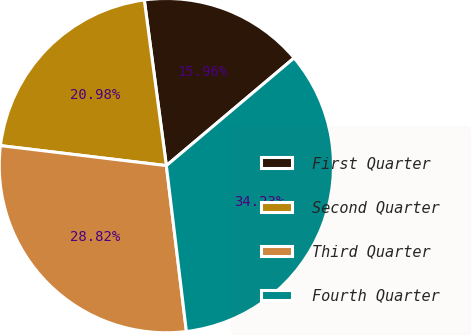<chart> <loc_0><loc_0><loc_500><loc_500><pie_chart><fcel>First Quarter<fcel>Second Quarter<fcel>Third Quarter<fcel>Fourth Quarter<nl><fcel>15.96%<fcel>20.98%<fcel>28.82%<fcel>34.23%<nl></chart> 